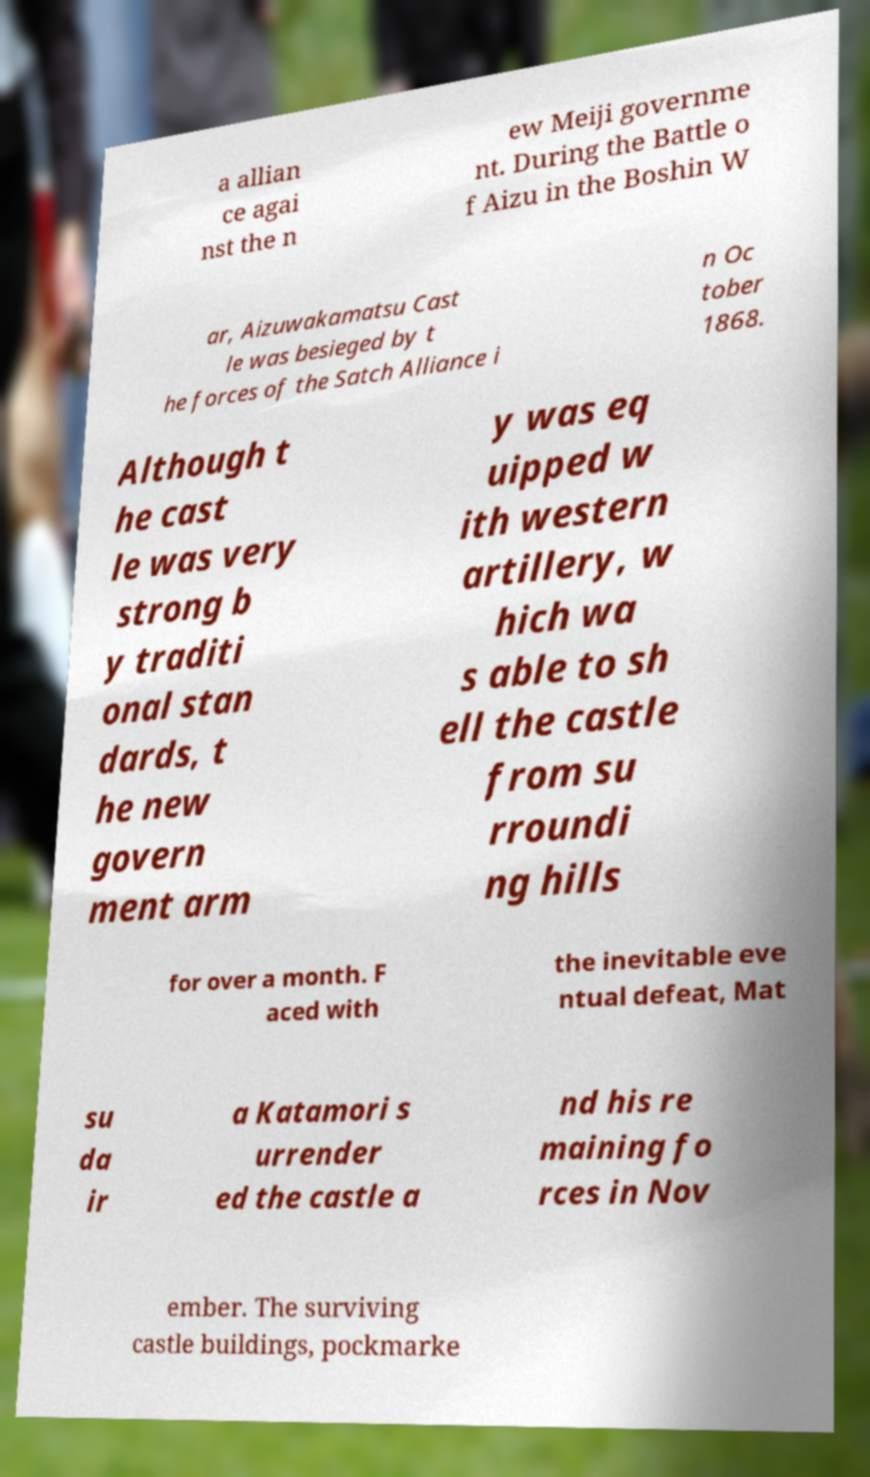I need the written content from this picture converted into text. Can you do that? a allian ce agai nst the n ew Meiji governme nt. During the Battle o f Aizu in the Boshin W ar, Aizuwakamatsu Cast le was besieged by t he forces of the Satch Alliance i n Oc tober 1868. Although t he cast le was very strong b y traditi onal stan dards, t he new govern ment arm y was eq uipped w ith western artillery, w hich wa s able to sh ell the castle from su rroundi ng hills for over a month. F aced with the inevitable eve ntual defeat, Mat su da ir a Katamori s urrender ed the castle a nd his re maining fo rces in Nov ember. The surviving castle buildings, pockmarke 